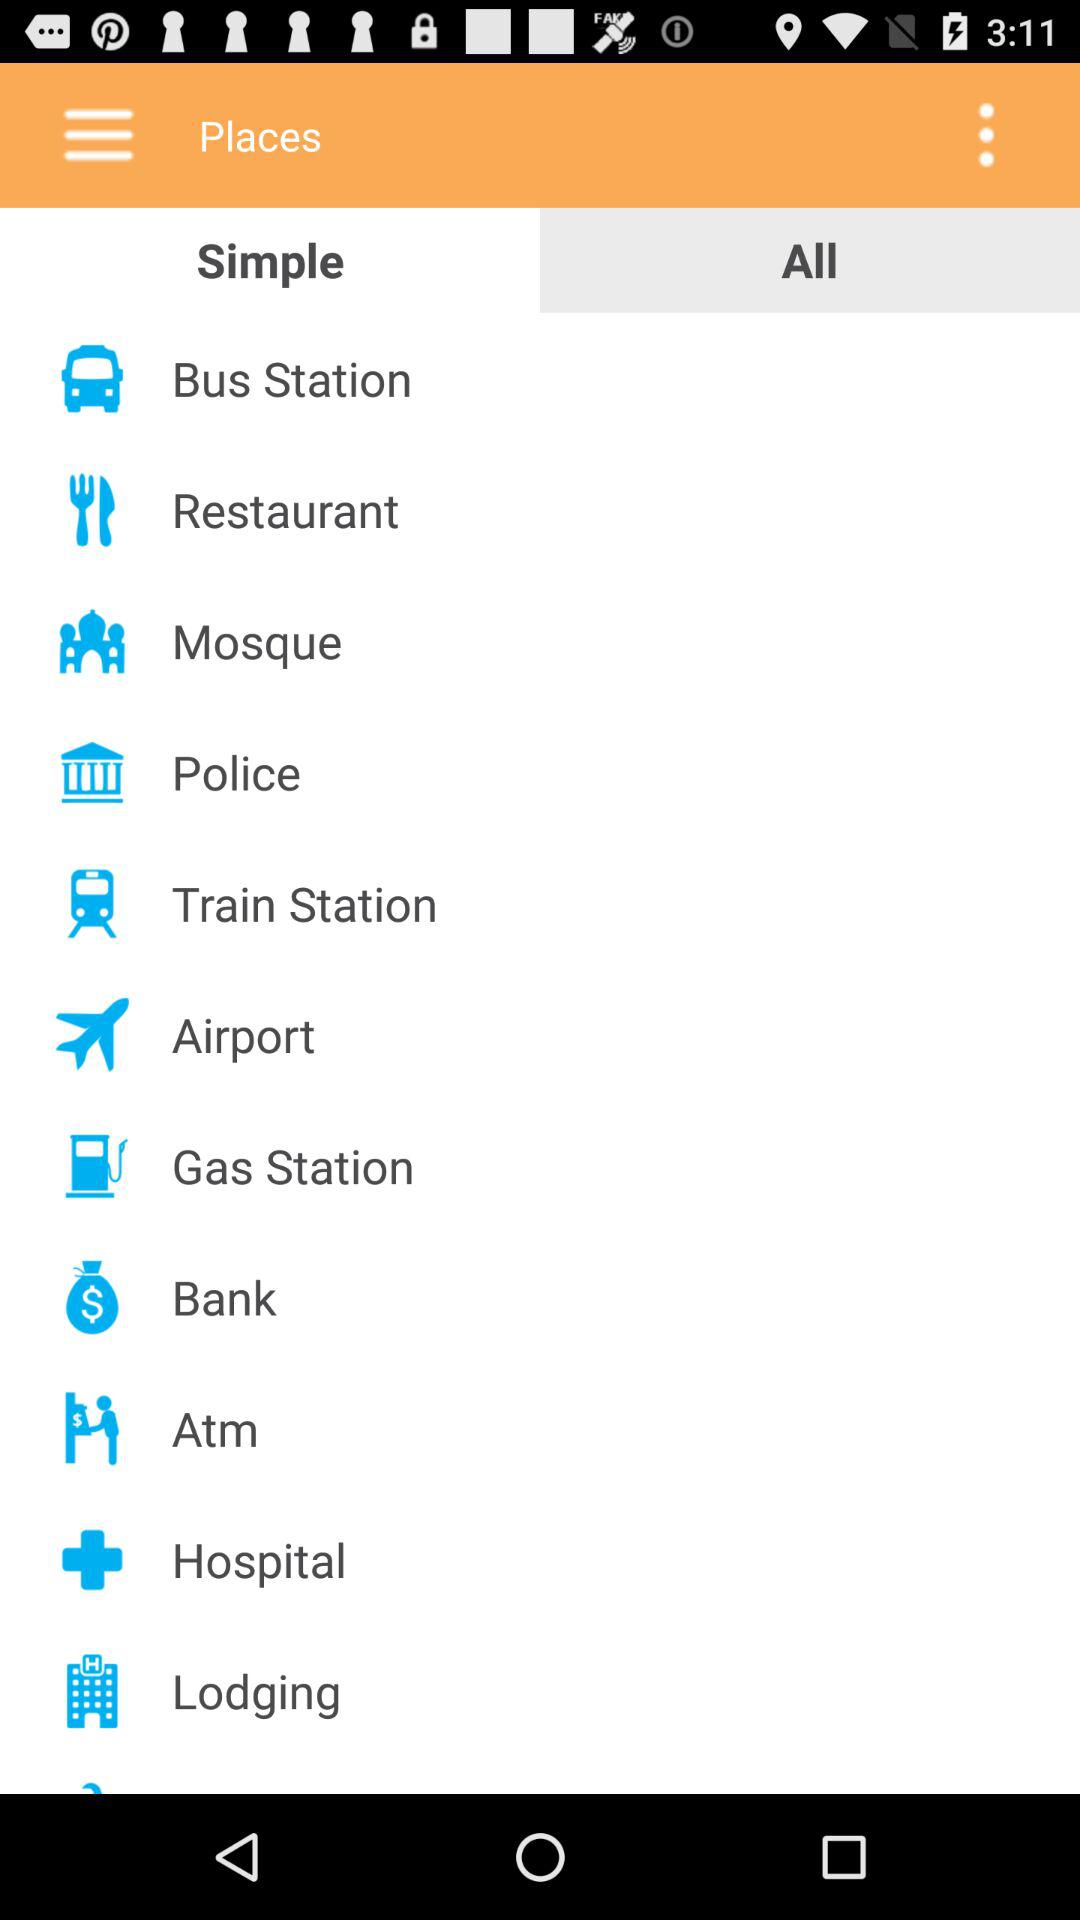How many notifications are there in "Bank"?
When the provided information is insufficient, respond with <no answer>. <no answer> 